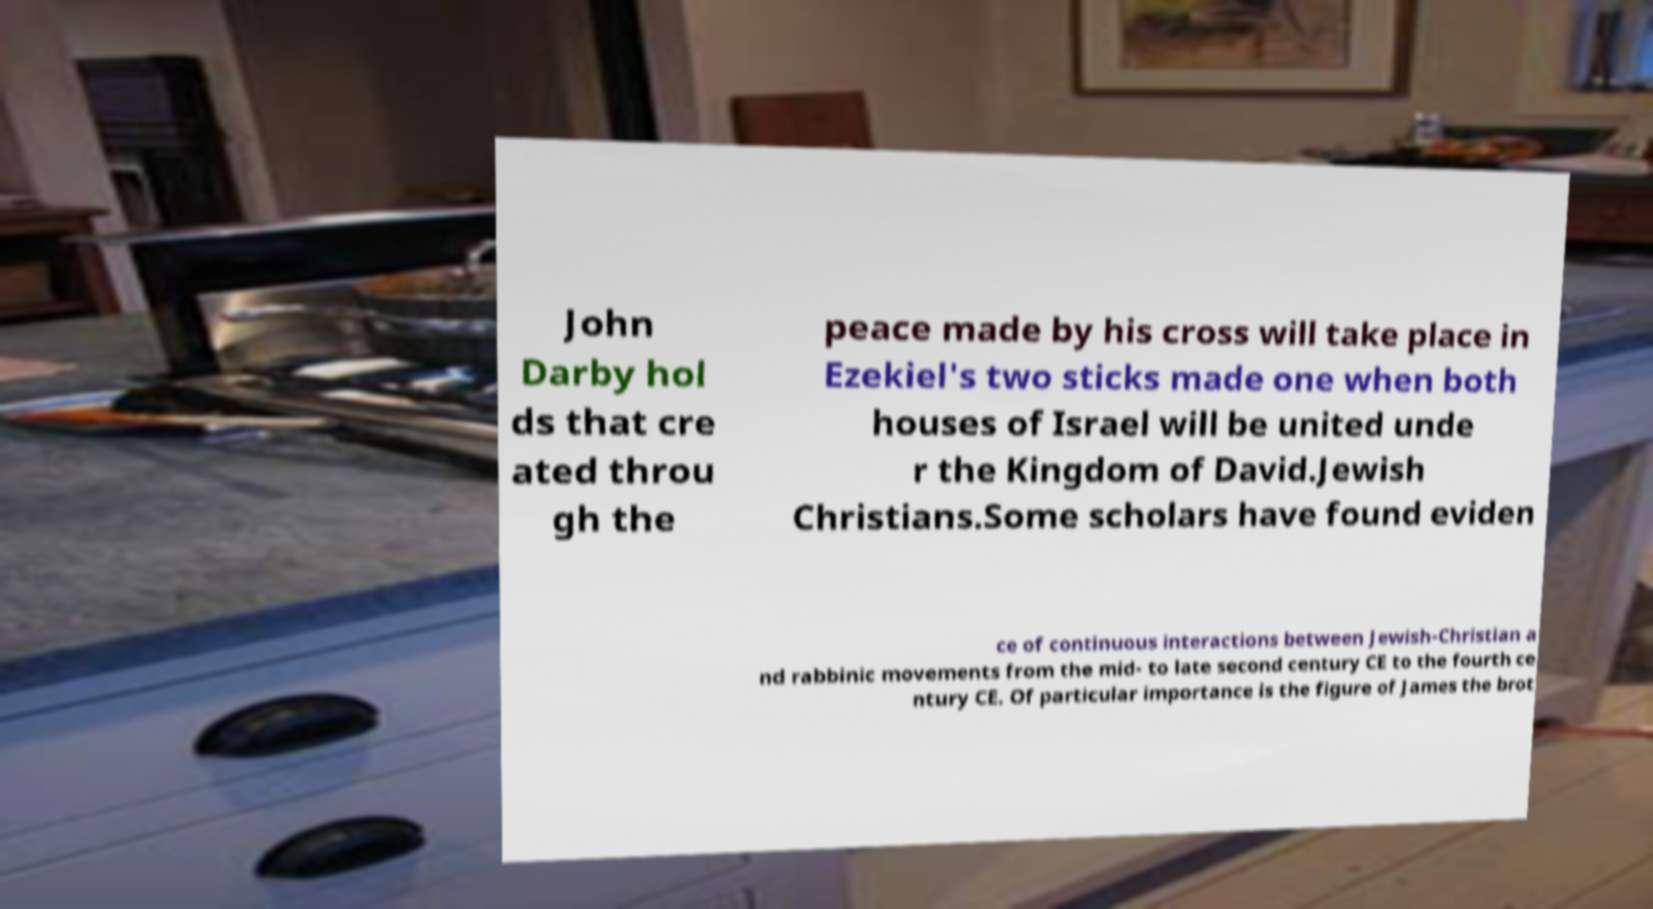Could you extract and type out the text from this image? John Darby hol ds that cre ated throu gh the peace made by his cross will take place in Ezekiel's two sticks made one when both houses of Israel will be united unde r the Kingdom of David.Jewish Christians.Some scholars have found eviden ce of continuous interactions between Jewish-Christian a nd rabbinic movements from the mid- to late second century CE to the fourth ce ntury CE. Of particular importance is the figure of James the brot 